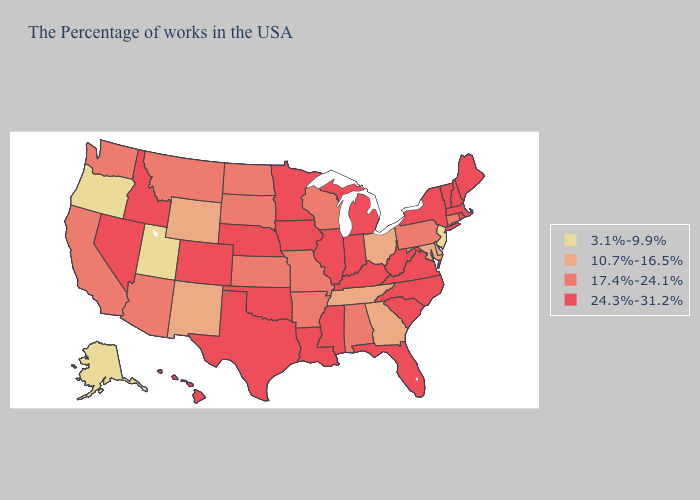What is the highest value in states that border Tennessee?
Quick response, please. 24.3%-31.2%. Name the states that have a value in the range 3.1%-9.9%?
Keep it brief. New Jersey, Utah, Oregon, Alaska. Name the states that have a value in the range 24.3%-31.2%?
Keep it brief. Maine, Massachusetts, Rhode Island, New Hampshire, Vermont, New York, Virginia, North Carolina, South Carolina, West Virginia, Florida, Michigan, Kentucky, Indiana, Illinois, Mississippi, Louisiana, Minnesota, Iowa, Nebraska, Oklahoma, Texas, Colorado, Idaho, Nevada, Hawaii. Which states hav the highest value in the Northeast?
Be succinct. Maine, Massachusetts, Rhode Island, New Hampshire, Vermont, New York. What is the highest value in the USA?
Give a very brief answer. 24.3%-31.2%. Does the first symbol in the legend represent the smallest category?
Short answer required. Yes. What is the value of Florida?
Be succinct. 24.3%-31.2%. Is the legend a continuous bar?
Give a very brief answer. No. What is the value of Nevada?
Short answer required. 24.3%-31.2%. Is the legend a continuous bar?
Write a very short answer. No. What is the lowest value in states that border Iowa?
Quick response, please. 17.4%-24.1%. Which states have the highest value in the USA?
Give a very brief answer. Maine, Massachusetts, Rhode Island, New Hampshire, Vermont, New York, Virginia, North Carolina, South Carolina, West Virginia, Florida, Michigan, Kentucky, Indiana, Illinois, Mississippi, Louisiana, Minnesota, Iowa, Nebraska, Oklahoma, Texas, Colorado, Idaho, Nevada, Hawaii. Does New Jersey have the lowest value in the USA?
Be succinct. Yes. Which states have the lowest value in the Northeast?
Short answer required. New Jersey. 